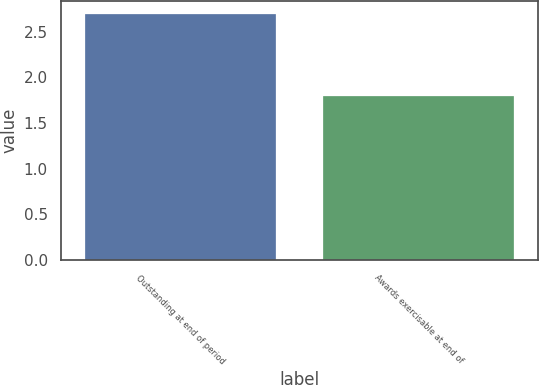Convert chart to OTSL. <chart><loc_0><loc_0><loc_500><loc_500><bar_chart><fcel>Outstanding at end of period<fcel>Awards exercisable at end of<nl><fcel>2.7<fcel>1.8<nl></chart> 